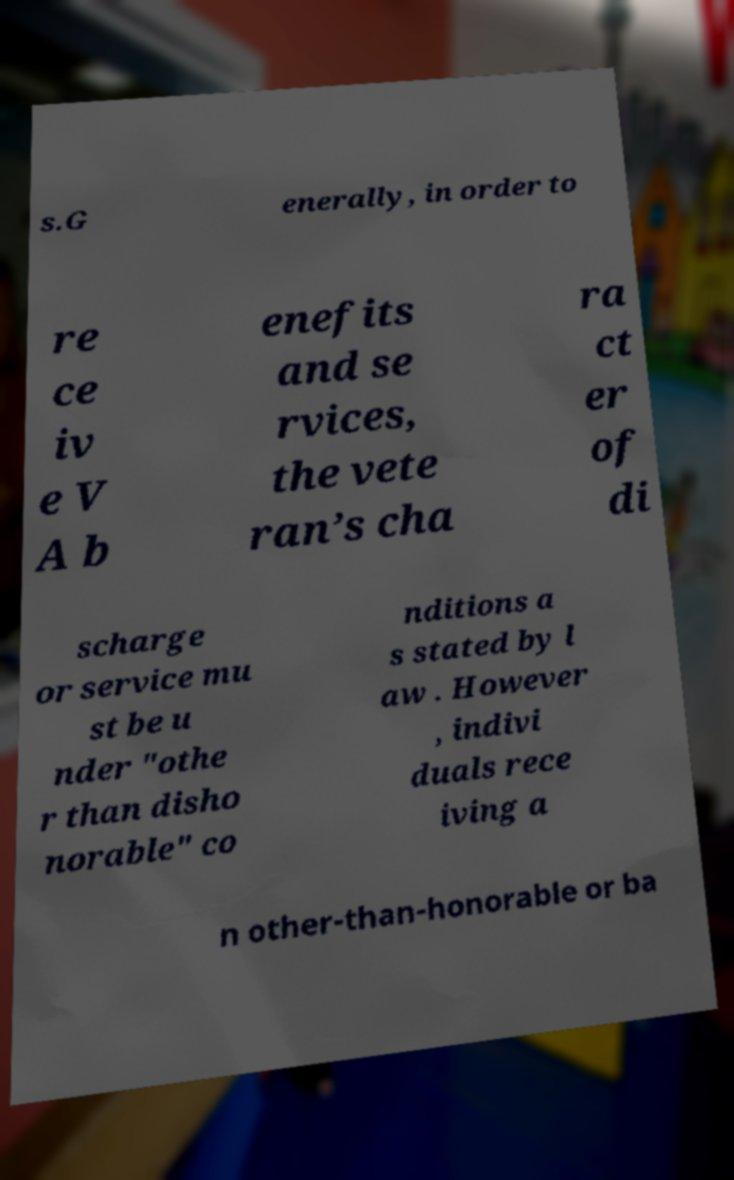Can you read and provide the text displayed in the image?This photo seems to have some interesting text. Can you extract and type it out for me? s.G enerally, in order to re ce iv e V A b enefits and se rvices, the vete ran’s cha ra ct er of di scharge or service mu st be u nder "othe r than disho norable" co nditions a s stated by l aw . However , indivi duals rece iving a n other-than-honorable or ba 